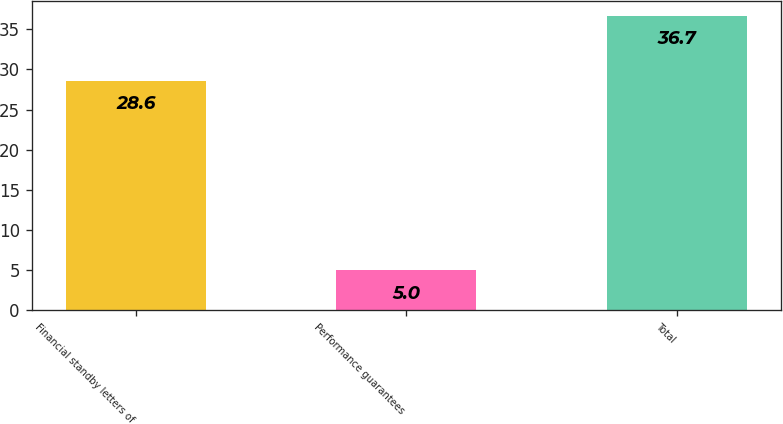<chart> <loc_0><loc_0><loc_500><loc_500><bar_chart><fcel>Financial standby letters of<fcel>Performance guarantees<fcel>Total<nl><fcel>28.6<fcel>5<fcel>36.7<nl></chart> 